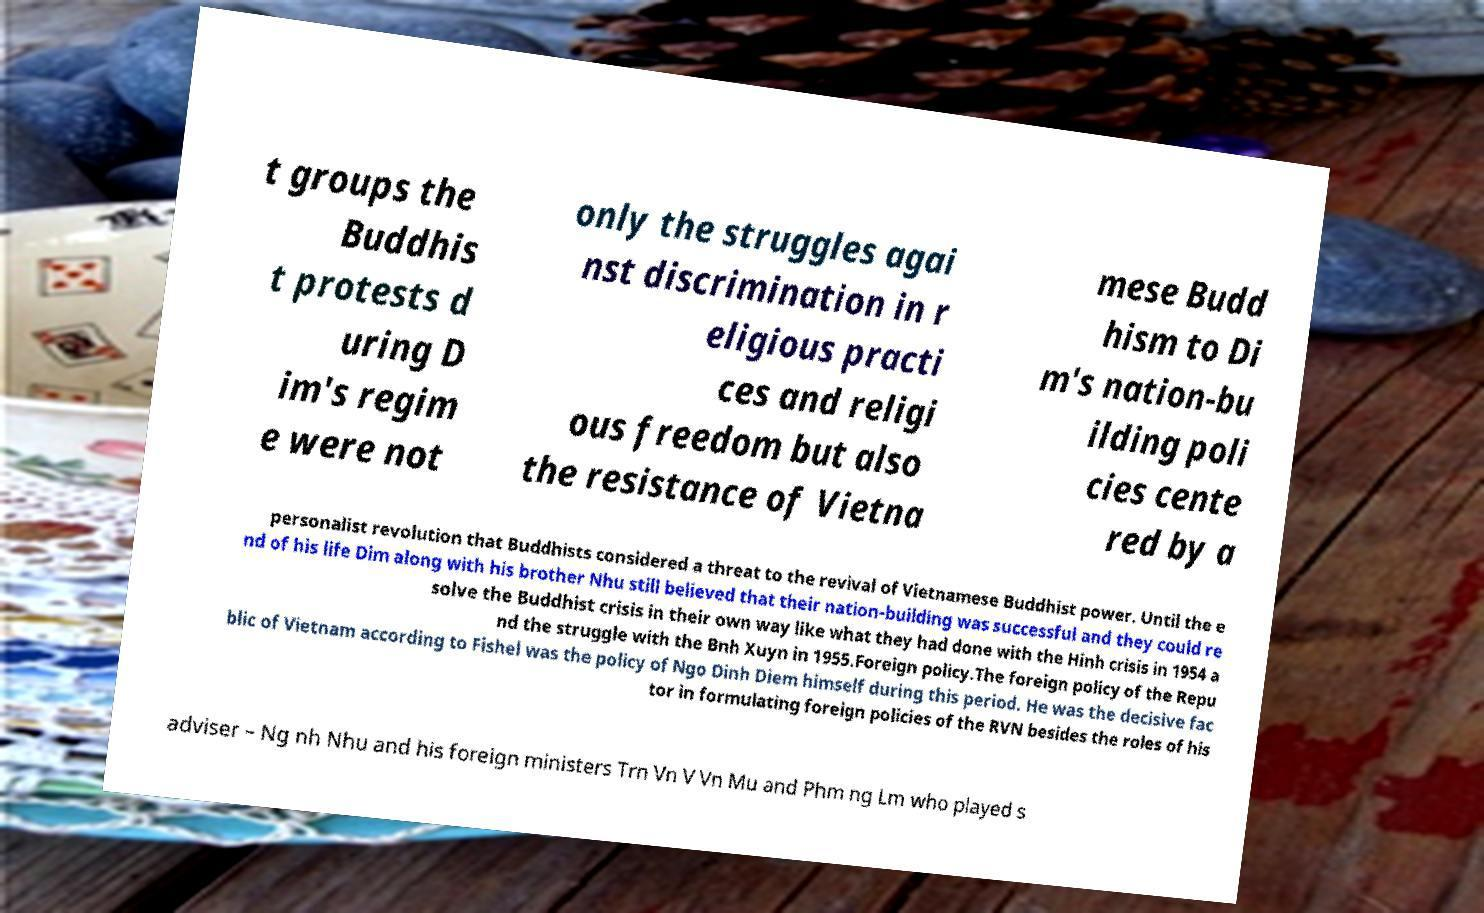What messages or text are displayed in this image? I need them in a readable, typed format. t groups the Buddhis t protests d uring D im's regim e were not only the struggles agai nst discrimination in r eligious practi ces and religi ous freedom but also the resistance of Vietna mese Budd hism to Di m's nation-bu ilding poli cies cente red by a personalist revolution that Buddhists considered a threat to the revival of Vietnamese Buddhist power. Until the e nd of his life Dim along with his brother Nhu still believed that their nation-building was successful and they could re solve the Buddhist crisis in their own way like what they had done with the Hinh crisis in 1954 a nd the struggle with the Bnh Xuyn in 1955.Foreign policy.The foreign policy of the Repu blic of Vietnam according to Fishel was the policy of Ngo Dinh Diem himself during this period. He was the decisive fac tor in formulating foreign policies of the RVN besides the roles of his adviser – Ng nh Nhu and his foreign ministers Trn Vn V Vn Mu and Phm ng Lm who played s 